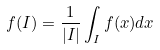<formula> <loc_0><loc_0><loc_500><loc_500>f ( I ) = \frac { 1 } { | I | } \int _ { I } f ( x ) d x</formula> 